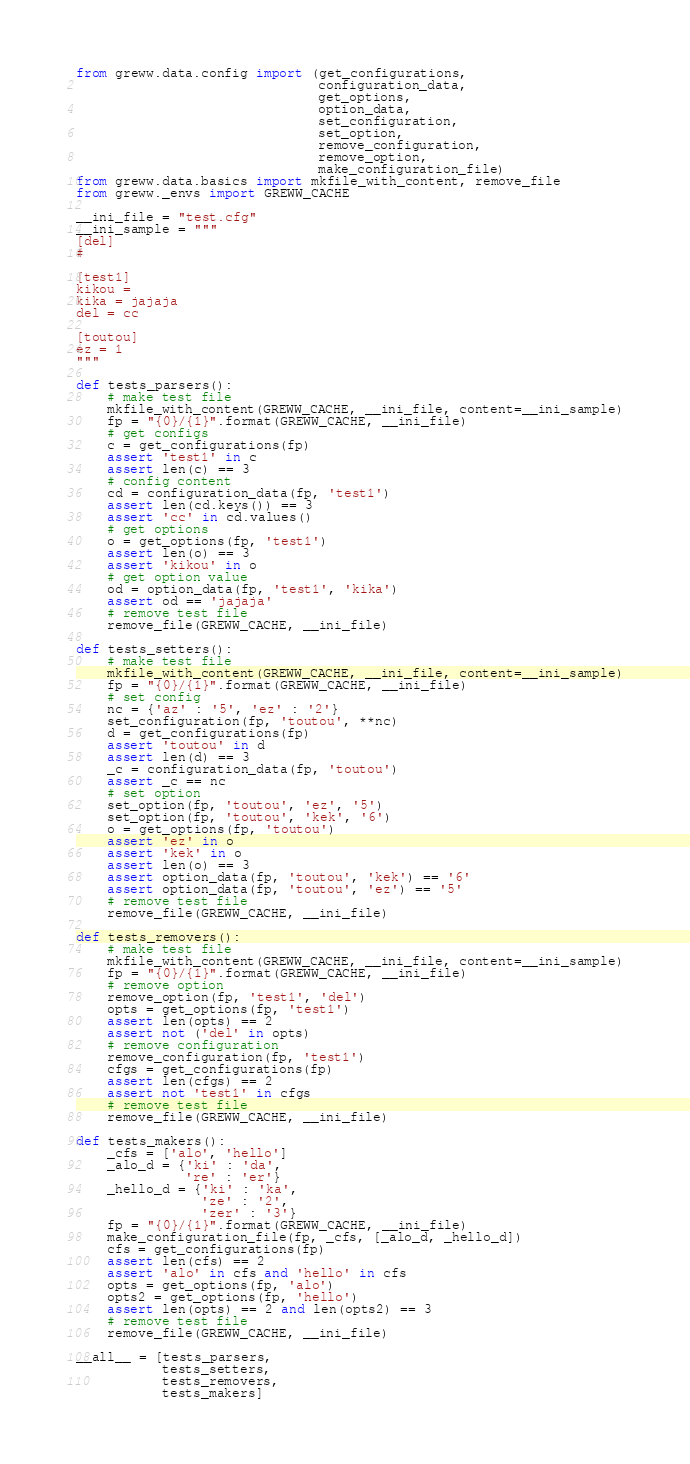<code> <loc_0><loc_0><loc_500><loc_500><_Python_>from greww.data.config import (get_configurations,
                               configuration_data,
                               get_options,
                               option_data,
                               set_configuration,
                               set_option,
                               remove_configuration,
                               remove_option,
                               make_configuration_file)
from greww.data.basics import mkfile_with_content, remove_file
from greww._envs import GREWW_CACHE

__ini_file = "test.cfg"
__ini_sample = """
[del]
#

[test1]
kikou =
kika = jajaja
del = cc

[toutou]
ez = 1
"""

def tests_parsers():
    # make test file
    mkfile_with_content(GREWW_CACHE, __ini_file, content=__ini_sample)
    fp = "{0}/{1}".format(GREWW_CACHE, __ini_file)
    # get configs
    c = get_configurations(fp)
    assert 'test1' in c
    assert len(c) == 3
    # config content
    cd = configuration_data(fp, 'test1')
    assert len(cd.keys()) == 3
    assert 'cc' in cd.values()
    # get options
    o = get_options(fp, 'test1')
    assert len(o) == 3
    assert 'kikou' in o
    # get option value
    od = option_data(fp, 'test1', 'kika')
    assert od == 'jajaja'
    # remove test file
    remove_file(GREWW_CACHE, __ini_file)

def tests_setters():
    # make test file
    mkfile_with_content(GREWW_CACHE, __ini_file, content=__ini_sample)
    fp = "{0}/{1}".format(GREWW_CACHE, __ini_file)
    # set config
    nc = {'az' : '5', 'ez' : '2'}
    set_configuration(fp, 'toutou', **nc)
    d = get_configurations(fp)
    assert 'toutou' in d
    assert len(d) == 3
    _c = configuration_data(fp, 'toutou')
    assert _c == nc
    # set option
    set_option(fp, 'toutou', 'ez', '5')
    set_option(fp, 'toutou', 'kek', '6')
    o = get_options(fp, 'toutou')
    assert 'ez' in o
    assert 'kek' in o
    assert len(o) == 3
    assert option_data(fp, 'toutou', 'kek') == '6'
    assert option_data(fp, 'toutou', 'ez') == '5'
    # remove test file
    remove_file(GREWW_CACHE, __ini_file)

def tests_removers():
    # make test file
    mkfile_with_content(GREWW_CACHE, __ini_file, content=__ini_sample)
    fp = "{0}/{1}".format(GREWW_CACHE, __ini_file)
    # remove option
    remove_option(fp, 'test1', 'del')
    opts = get_options(fp, 'test1')
    assert len(opts) == 2
    assert not ('del' in opts)
    # remove configuration
    remove_configuration(fp, 'test1')
    cfgs = get_configurations(fp)
    assert len(cfgs) == 2
    assert not 'test1' in cfgs
    # remove test file
    remove_file(GREWW_CACHE, __ini_file)

def tests_makers():
    _cfs = ['alo', 'hello']
    _alo_d = {'ki' : 'da',
              're' : 'er'}
    _hello_d = {'ki' : 'ka',
                'ze' : '2',
                'zer' : '3'}
    fp = "{0}/{1}".format(GREWW_CACHE, __ini_file)
    make_configuration_file(fp, _cfs, [_alo_d, _hello_d])
    cfs = get_configurations(fp)
    assert len(cfs) == 2
    assert 'alo' in cfs and 'hello' in cfs
    opts = get_options(fp, 'alo')
    opts2 = get_options(fp, 'hello')
    assert len(opts) == 2 and len(opts2) == 3
    # remove test file
    remove_file(GREWW_CACHE, __ini_file)

__all__ = [tests_parsers,
           tests_setters,
           tests_removers,
           tests_makers]
</code> 